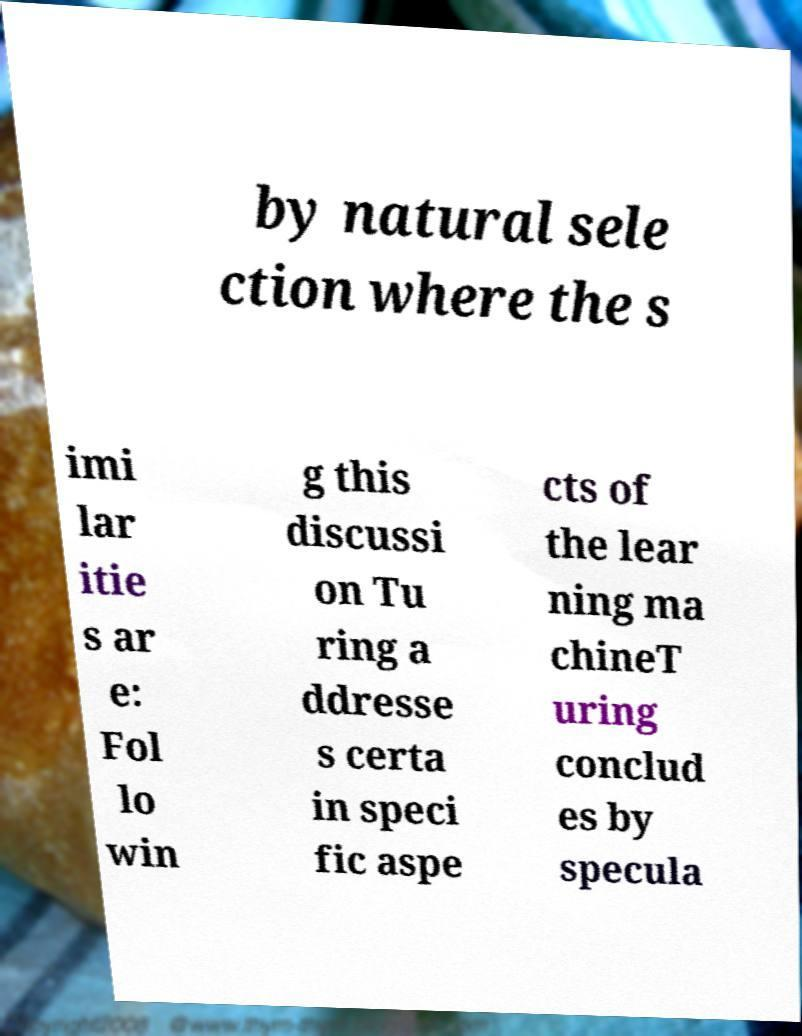For documentation purposes, I need the text within this image transcribed. Could you provide that? by natural sele ction where the s imi lar itie s ar e: Fol lo win g this discussi on Tu ring a ddresse s certa in speci fic aspe cts of the lear ning ma chineT uring conclud es by specula 